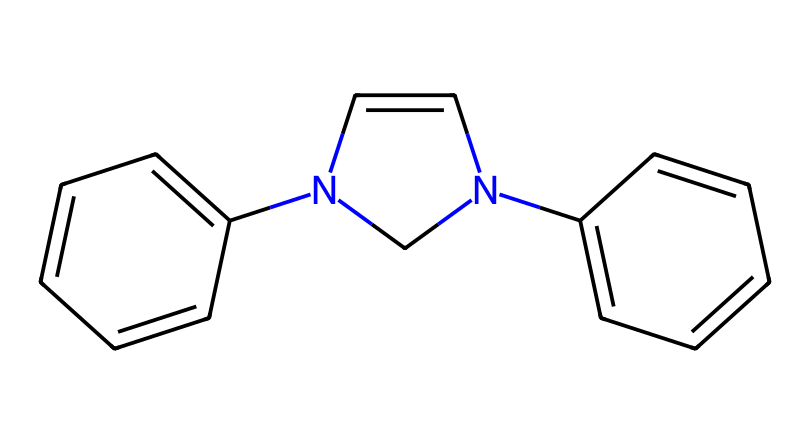What is the total number of carbon atoms in this compound? By examining the SMILES representation, we can identify that there are several 'C' characters indicating carbon atoms. Counting them gives a total of 15 carbon atoms.
Answer: 15 How many nitrogen atoms are present in this structure? The SMILES includes 'N' twice, which indicates there are two nitrogen atoms in the compound.
Answer: 2 What type of compound is represented by this chemical structure? The presence of nitrogen and the connectivity suggests this compound can be classified as an alkaloid, which is a common type of compound found in the restoration of artworks.
Answer: alkaloid What is the significance of the nitrogen atoms in this compound? The nitrogen atoms suggest the presence of electron-donating groups that can help in the stabilization of carbenes, which is critical for their reactivity in restoration processes.
Answer: stabilization How does the presence of the double bonds affect the reactivity of this compound? The presence of multiple double bonds (indicated by '=' in the SMILES) increases electron density around the molecule, which enhances the reactivity of the carbene species formed during restoration.
Answer: enhances reactivity What role do carbenes play in the restoration of historical artworks? Carbenes can act as reactive intermediates that facilitate the repair of color and binding agents in the artwork, thereby preserving historical integrity.
Answer: repair agents 